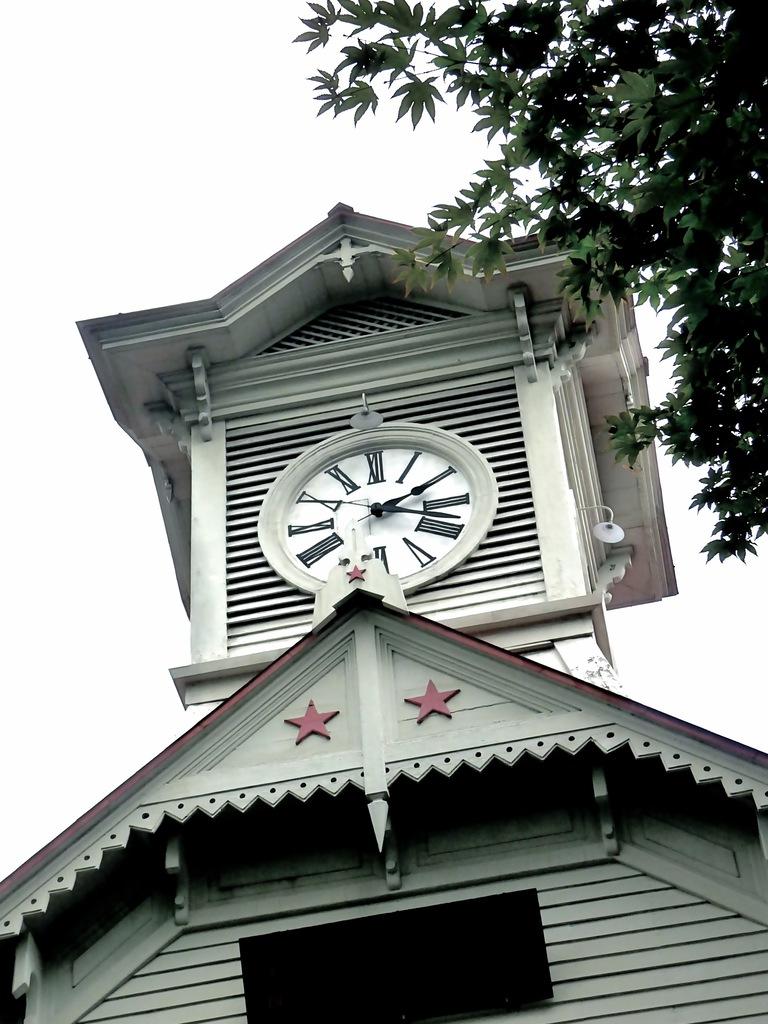What time is it?
Provide a succinct answer. 2:18. Are the numbers on the clock roman numerals?
Your response must be concise. Yes. 